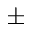<formula> <loc_0><loc_0><loc_500><loc_500>\pm</formula> 